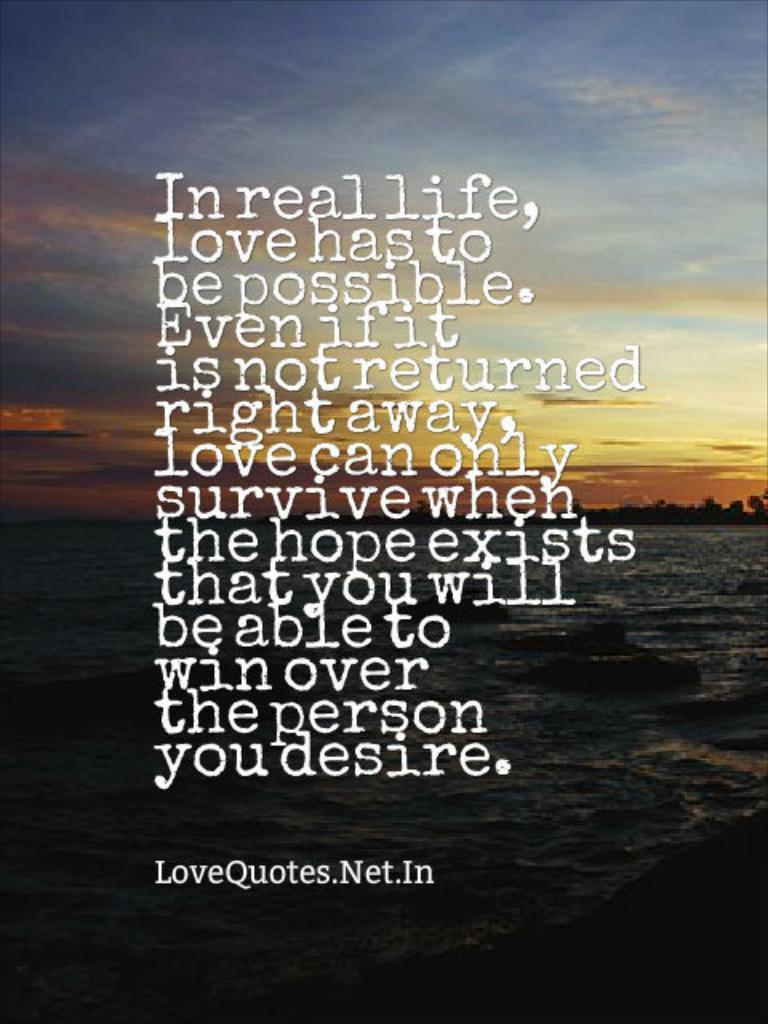Provide a one-sentence caption for the provided image. A quote from LoveQuotes.Net.In is written on a picture of the ocean. 